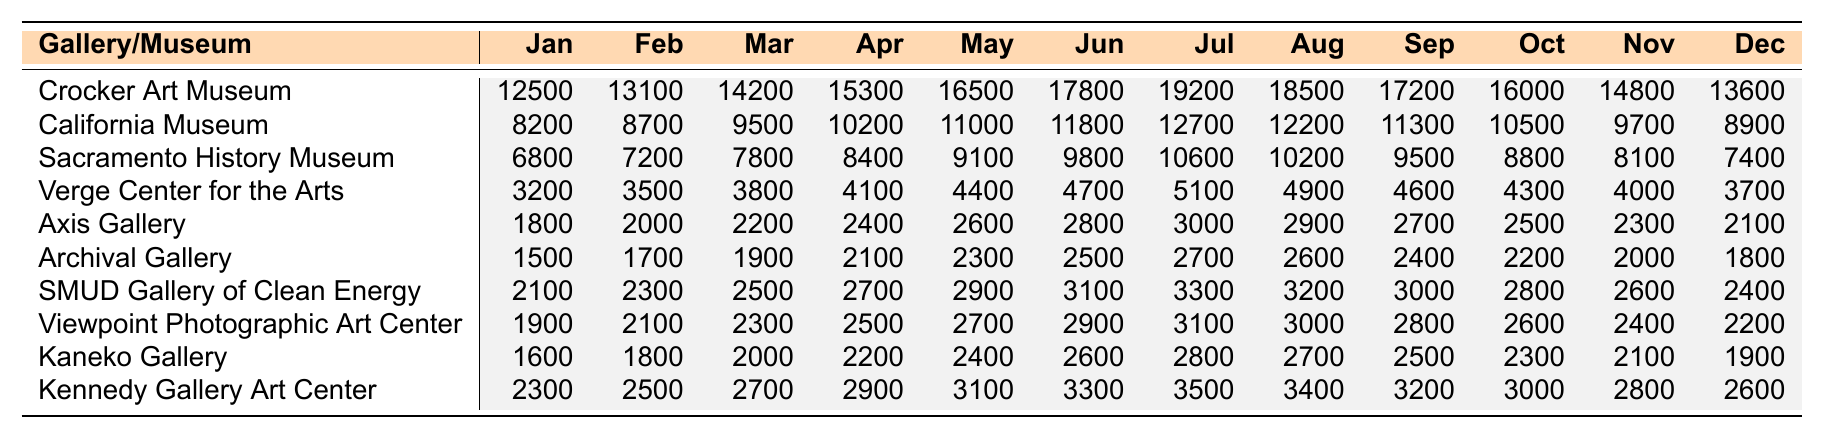What was the foot traffic for the Crocker Art Museum in June 2023? From the table, the value for the Crocker Art Museum under June is found in the respective row, which shows 17,800.
Answer: 17,800 Which gallery had the lowest foot traffic in April 2023? By comparing the foot traffic numbers for all galleries in April, Axis Gallery has the lowest value at 2,400.
Answer: Axis Gallery What is the average foot traffic for the California Museum from January to December 2023? To calculate the average, we sum the monthly values (8,200 + 8,700 + 9,500 + 10,200 + 11,000 + 11,800 + 12,700 + 12,200 + 11,300 + 10,500 + 9,700 + 8,900 = 133,800) and then divide by 12, which leads to 133,800 / 12 = 11,150.
Answer: 11,150 Did the foot traffic for the Kennedy Gallery Art Center increase every month from January to July 2023? Analyzing the numbers shows an increase each month: 2,300 (Jan), 2,500 (Feb), 2,700 (Mar), 2,900 (Apr), 3,100 (May), 3,300 (Jun), 3,500 (Jul). Therefore, the answer is yes.
Answer: Yes What is the total foot traffic for the Verge Center for the Arts during the months of May and June 2023? To find this, we sum the foot traffic values for those months: 4,400 (May) + 4,700 (Jun) = 9,100.
Answer: 9,100 Which gallery had a decrease in foot traffic from August to September 2023? By checking the values from August (4,900) and September (4,600) for the Verge Center for the Arts, it shows a drop indicating that this gallery experienced a decrease.
Answer: Verge Center for the Arts What is the difference in foot traffic between the highest and lowest galleries in December 2023? In December, the highest is Crocker Art Museum at 13,600 and the lowest is Archival Gallery at 1,800. The difference is 13,600 - 1,800 = 11,800.
Answer: 11,800 Which gallery had the highest foot traffic in February 2023? Checking February numbers, the California Museum recorded 8,700, but the highest foot traffic is for the Crocker Art Museum at 13,100.
Answer: Crocker Art Museum Calculate the total foot traffic for the SMUD Gallery of Clean Energy across all months listed. The total is calculated by adding all the monthly figures: 2,100 + 2,300 + 2,500 + 2,700 + 2,900 + 3,100 + 3,300 + 3,200 + 3,000 + 2,800 + 2,600 + 2,400 = 34,200.
Answer: 34,200 Was there any month in 2023 where the foot traffic for the Axis Gallery was higher than 3,000? By checking the table, all monthly values for Axis Gallery are below 3,000, confirming the answer is no.
Answer: No 